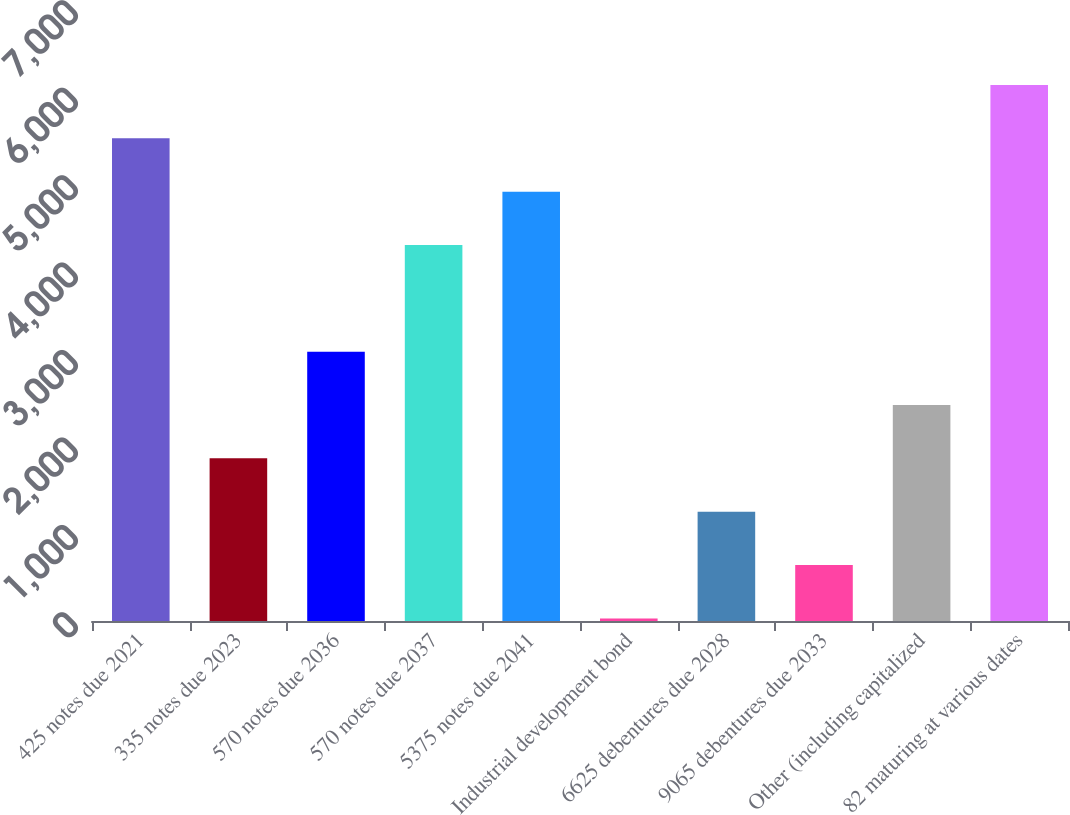Convert chart. <chart><loc_0><loc_0><loc_500><loc_500><bar_chart><fcel>425 notes due 2021<fcel>335 notes due 2023<fcel>570 notes due 2036<fcel>570 notes due 2037<fcel>5375 notes due 2041<fcel>Industrial development bond<fcel>6625 debentures due 2028<fcel>9065 debentures due 2033<fcel>Other (including capitalized<fcel>82 maturing at various dates<nl><fcel>5520.9<fcel>1860.3<fcel>3080.5<fcel>4300.7<fcel>4910.8<fcel>30<fcel>1250.2<fcel>640.1<fcel>2470.4<fcel>6131<nl></chart> 